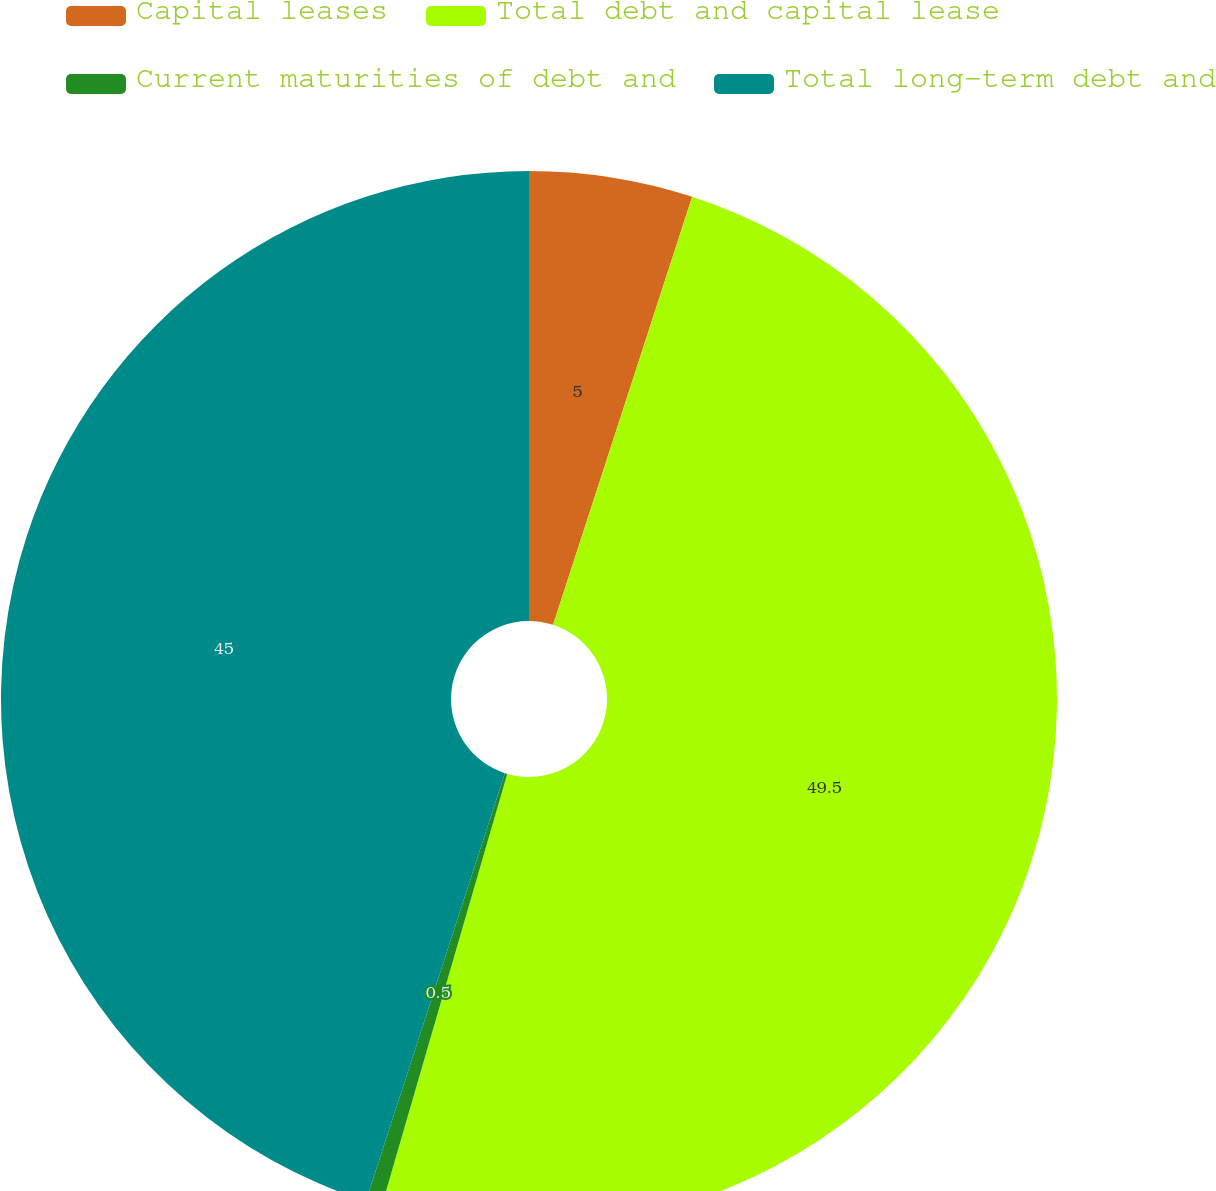Convert chart. <chart><loc_0><loc_0><loc_500><loc_500><pie_chart><fcel>Capital leases<fcel>Total debt and capital lease<fcel>Current maturities of debt and<fcel>Total long-term debt and<nl><fcel>5.0%<fcel>49.5%<fcel>0.5%<fcel>45.0%<nl></chart> 